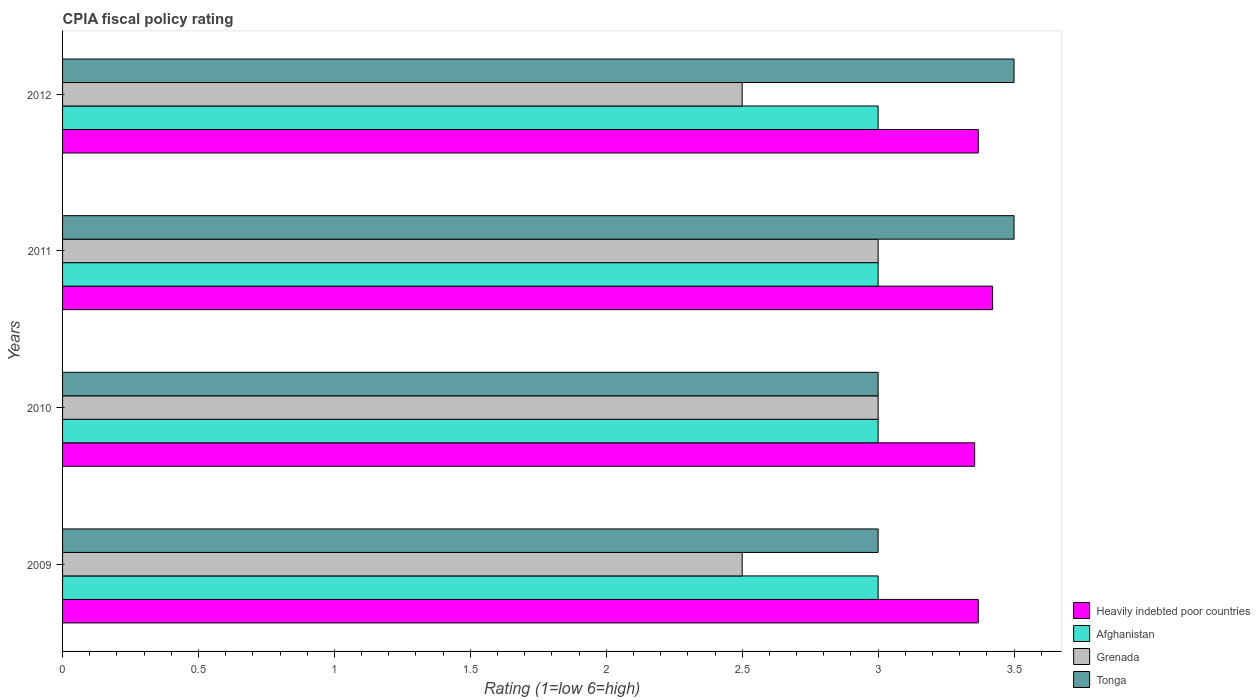How many groups of bars are there?
Offer a very short reply. 4. Are the number of bars per tick equal to the number of legend labels?
Ensure brevity in your answer.  Yes. Are the number of bars on each tick of the Y-axis equal?
Your answer should be very brief. Yes. How many bars are there on the 2nd tick from the top?
Your answer should be compact. 4. Across all years, what is the maximum CPIA rating in Grenada?
Keep it short and to the point. 3. Across all years, what is the minimum CPIA rating in Heavily indebted poor countries?
Keep it short and to the point. 3.36. In which year was the CPIA rating in Tonga maximum?
Your answer should be very brief. 2011. In which year was the CPIA rating in Afghanistan minimum?
Offer a very short reply. 2009. What is the difference between the CPIA rating in Grenada in 2009 and that in 2010?
Offer a terse response. -0.5. What is the difference between the CPIA rating in Grenada in 2009 and the CPIA rating in Tonga in 2011?
Keep it short and to the point. -1. What is the average CPIA rating in Grenada per year?
Your response must be concise. 2.75. In the year 2010, what is the difference between the CPIA rating in Grenada and CPIA rating in Heavily indebted poor countries?
Offer a very short reply. -0.36. In how many years, is the CPIA rating in Tonga greater than 0.7 ?
Make the answer very short. 4. What is the ratio of the CPIA rating in Heavily indebted poor countries in 2009 to that in 2010?
Your answer should be very brief. 1. What is the difference between the highest and the second highest CPIA rating in Heavily indebted poor countries?
Offer a terse response. 0.05. Is it the case that in every year, the sum of the CPIA rating in Heavily indebted poor countries and CPIA rating in Tonga is greater than the sum of CPIA rating in Grenada and CPIA rating in Afghanistan?
Your answer should be compact. No. What does the 2nd bar from the top in 2010 represents?
Your answer should be very brief. Grenada. What does the 3rd bar from the bottom in 2009 represents?
Your response must be concise. Grenada. How many bars are there?
Give a very brief answer. 16. Are the values on the major ticks of X-axis written in scientific E-notation?
Offer a very short reply. No. How are the legend labels stacked?
Provide a short and direct response. Vertical. What is the title of the graph?
Offer a terse response. CPIA fiscal policy rating. What is the Rating (1=low 6=high) of Heavily indebted poor countries in 2009?
Your response must be concise. 3.37. What is the Rating (1=low 6=high) of Afghanistan in 2009?
Give a very brief answer. 3. What is the Rating (1=low 6=high) in Tonga in 2009?
Keep it short and to the point. 3. What is the Rating (1=low 6=high) of Heavily indebted poor countries in 2010?
Ensure brevity in your answer.  3.36. What is the Rating (1=low 6=high) in Grenada in 2010?
Keep it short and to the point. 3. What is the Rating (1=low 6=high) in Tonga in 2010?
Provide a succinct answer. 3. What is the Rating (1=low 6=high) of Heavily indebted poor countries in 2011?
Provide a short and direct response. 3.42. What is the Rating (1=low 6=high) in Afghanistan in 2011?
Ensure brevity in your answer.  3. What is the Rating (1=low 6=high) of Grenada in 2011?
Your answer should be very brief. 3. What is the Rating (1=low 6=high) in Tonga in 2011?
Offer a very short reply. 3.5. What is the Rating (1=low 6=high) of Heavily indebted poor countries in 2012?
Provide a short and direct response. 3.37. What is the Rating (1=low 6=high) in Grenada in 2012?
Your answer should be compact. 2.5. Across all years, what is the maximum Rating (1=low 6=high) in Heavily indebted poor countries?
Give a very brief answer. 3.42. Across all years, what is the minimum Rating (1=low 6=high) of Heavily indebted poor countries?
Offer a terse response. 3.36. Across all years, what is the minimum Rating (1=low 6=high) in Afghanistan?
Your answer should be very brief. 3. Across all years, what is the minimum Rating (1=low 6=high) in Tonga?
Your answer should be very brief. 3. What is the total Rating (1=low 6=high) of Heavily indebted poor countries in the graph?
Your answer should be very brief. 13.51. What is the total Rating (1=low 6=high) in Grenada in the graph?
Make the answer very short. 11. What is the difference between the Rating (1=low 6=high) in Heavily indebted poor countries in 2009 and that in 2010?
Your response must be concise. 0.01. What is the difference between the Rating (1=low 6=high) in Grenada in 2009 and that in 2010?
Keep it short and to the point. -0.5. What is the difference between the Rating (1=low 6=high) of Tonga in 2009 and that in 2010?
Make the answer very short. 0. What is the difference between the Rating (1=low 6=high) in Heavily indebted poor countries in 2009 and that in 2011?
Your answer should be compact. -0.05. What is the difference between the Rating (1=low 6=high) in Heavily indebted poor countries in 2009 and that in 2012?
Make the answer very short. 0. What is the difference between the Rating (1=low 6=high) in Afghanistan in 2009 and that in 2012?
Make the answer very short. 0. What is the difference between the Rating (1=low 6=high) in Tonga in 2009 and that in 2012?
Offer a very short reply. -0.5. What is the difference between the Rating (1=low 6=high) in Heavily indebted poor countries in 2010 and that in 2011?
Ensure brevity in your answer.  -0.07. What is the difference between the Rating (1=low 6=high) of Grenada in 2010 and that in 2011?
Provide a succinct answer. 0. What is the difference between the Rating (1=low 6=high) of Heavily indebted poor countries in 2010 and that in 2012?
Your answer should be very brief. -0.01. What is the difference between the Rating (1=low 6=high) of Afghanistan in 2010 and that in 2012?
Provide a succinct answer. 0. What is the difference between the Rating (1=low 6=high) in Tonga in 2010 and that in 2012?
Make the answer very short. -0.5. What is the difference between the Rating (1=low 6=high) in Heavily indebted poor countries in 2011 and that in 2012?
Offer a very short reply. 0.05. What is the difference between the Rating (1=low 6=high) in Afghanistan in 2011 and that in 2012?
Provide a succinct answer. 0. What is the difference between the Rating (1=low 6=high) in Heavily indebted poor countries in 2009 and the Rating (1=low 6=high) in Afghanistan in 2010?
Your response must be concise. 0.37. What is the difference between the Rating (1=low 6=high) in Heavily indebted poor countries in 2009 and the Rating (1=low 6=high) in Grenada in 2010?
Your response must be concise. 0.37. What is the difference between the Rating (1=low 6=high) in Heavily indebted poor countries in 2009 and the Rating (1=low 6=high) in Tonga in 2010?
Provide a short and direct response. 0.37. What is the difference between the Rating (1=low 6=high) in Afghanistan in 2009 and the Rating (1=low 6=high) in Grenada in 2010?
Your answer should be very brief. 0. What is the difference between the Rating (1=low 6=high) of Grenada in 2009 and the Rating (1=low 6=high) of Tonga in 2010?
Give a very brief answer. -0.5. What is the difference between the Rating (1=low 6=high) of Heavily indebted poor countries in 2009 and the Rating (1=low 6=high) of Afghanistan in 2011?
Make the answer very short. 0.37. What is the difference between the Rating (1=low 6=high) of Heavily indebted poor countries in 2009 and the Rating (1=low 6=high) of Grenada in 2011?
Your response must be concise. 0.37. What is the difference between the Rating (1=low 6=high) in Heavily indebted poor countries in 2009 and the Rating (1=low 6=high) in Tonga in 2011?
Give a very brief answer. -0.13. What is the difference between the Rating (1=low 6=high) of Afghanistan in 2009 and the Rating (1=low 6=high) of Grenada in 2011?
Provide a succinct answer. 0. What is the difference between the Rating (1=low 6=high) of Heavily indebted poor countries in 2009 and the Rating (1=low 6=high) of Afghanistan in 2012?
Provide a succinct answer. 0.37. What is the difference between the Rating (1=low 6=high) in Heavily indebted poor countries in 2009 and the Rating (1=low 6=high) in Grenada in 2012?
Your response must be concise. 0.87. What is the difference between the Rating (1=low 6=high) in Heavily indebted poor countries in 2009 and the Rating (1=low 6=high) in Tonga in 2012?
Your answer should be compact. -0.13. What is the difference between the Rating (1=low 6=high) of Afghanistan in 2009 and the Rating (1=low 6=high) of Grenada in 2012?
Provide a short and direct response. 0.5. What is the difference between the Rating (1=low 6=high) of Grenada in 2009 and the Rating (1=low 6=high) of Tonga in 2012?
Keep it short and to the point. -1. What is the difference between the Rating (1=low 6=high) of Heavily indebted poor countries in 2010 and the Rating (1=low 6=high) of Afghanistan in 2011?
Give a very brief answer. 0.36. What is the difference between the Rating (1=low 6=high) of Heavily indebted poor countries in 2010 and the Rating (1=low 6=high) of Grenada in 2011?
Your response must be concise. 0.36. What is the difference between the Rating (1=low 6=high) of Heavily indebted poor countries in 2010 and the Rating (1=low 6=high) of Tonga in 2011?
Keep it short and to the point. -0.14. What is the difference between the Rating (1=low 6=high) in Afghanistan in 2010 and the Rating (1=low 6=high) in Grenada in 2011?
Your answer should be compact. 0. What is the difference between the Rating (1=low 6=high) of Heavily indebted poor countries in 2010 and the Rating (1=low 6=high) of Afghanistan in 2012?
Your answer should be compact. 0.36. What is the difference between the Rating (1=low 6=high) in Heavily indebted poor countries in 2010 and the Rating (1=low 6=high) in Grenada in 2012?
Offer a very short reply. 0.86. What is the difference between the Rating (1=low 6=high) in Heavily indebted poor countries in 2010 and the Rating (1=low 6=high) in Tonga in 2012?
Keep it short and to the point. -0.14. What is the difference between the Rating (1=low 6=high) in Afghanistan in 2010 and the Rating (1=low 6=high) in Grenada in 2012?
Give a very brief answer. 0.5. What is the difference between the Rating (1=low 6=high) of Afghanistan in 2010 and the Rating (1=low 6=high) of Tonga in 2012?
Offer a terse response. -0.5. What is the difference between the Rating (1=low 6=high) of Grenada in 2010 and the Rating (1=low 6=high) of Tonga in 2012?
Offer a terse response. -0.5. What is the difference between the Rating (1=low 6=high) of Heavily indebted poor countries in 2011 and the Rating (1=low 6=high) of Afghanistan in 2012?
Provide a succinct answer. 0.42. What is the difference between the Rating (1=low 6=high) of Heavily indebted poor countries in 2011 and the Rating (1=low 6=high) of Grenada in 2012?
Provide a short and direct response. 0.92. What is the difference between the Rating (1=low 6=high) of Heavily indebted poor countries in 2011 and the Rating (1=low 6=high) of Tonga in 2012?
Your answer should be compact. -0.08. What is the difference between the Rating (1=low 6=high) in Afghanistan in 2011 and the Rating (1=low 6=high) in Tonga in 2012?
Ensure brevity in your answer.  -0.5. What is the difference between the Rating (1=low 6=high) of Grenada in 2011 and the Rating (1=low 6=high) of Tonga in 2012?
Provide a succinct answer. -0.5. What is the average Rating (1=low 6=high) in Heavily indebted poor countries per year?
Keep it short and to the point. 3.38. What is the average Rating (1=low 6=high) of Afghanistan per year?
Offer a terse response. 3. What is the average Rating (1=low 6=high) of Grenada per year?
Offer a very short reply. 2.75. What is the average Rating (1=low 6=high) of Tonga per year?
Provide a short and direct response. 3.25. In the year 2009, what is the difference between the Rating (1=low 6=high) of Heavily indebted poor countries and Rating (1=low 6=high) of Afghanistan?
Give a very brief answer. 0.37. In the year 2009, what is the difference between the Rating (1=low 6=high) in Heavily indebted poor countries and Rating (1=low 6=high) in Grenada?
Your response must be concise. 0.87. In the year 2009, what is the difference between the Rating (1=low 6=high) of Heavily indebted poor countries and Rating (1=low 6=high) of Tonga?
Offer a very short reply. 0.37. In the year 2009, what is the difference between the Rating (1=low 6=high) in Afghanistan and Rating (1=low 6=high) in Tonga?
Your answer should be very brief. 0. In the year 2009, what is the difference between the Rating (1=low 6=high) in Grenada and Rating (1=low 6=high) in Tonga?
Provide a succinct answer. -0.5. In the year 2010, what is the difference between the Rating (1=low 6=high) in Heavily indebted poor countries and Rating (1=low 6=high) in Afghanistan?
Give a very brief answer. 0.36. In the year 2010, what is the difference between the Rating (1=low 6=high) of Heavily indebted poor countries and Rating (1=low 6=high) of Grenada?
Offer a very short reply. 0.36. In the year 2010, what is the difference between the Rating (1=low 6=high) of Heavily indebted poor countries and Rating (1=low 6=high) of Tonga?
Provide a succinct answer. 0.36. In the year 2010, what is the difference between the Rating (1=low 6=high) in Afghanistan and Rating (1=low 6=high) in Grenada?
Make the answer very short. 0. In the year 2011, what is the difference between the Rating (1=low 6=high) of Heavily indebted poor countries and Rating (1=low 6=high) of Afghanistan?
Provide a succinct answer. 0.42. In the year 2011, what is the difference between the Rating (1=low 6=high) in Heavily indebted poor countries and Rating (1=low 6=high) in Grenada?
Ensure brevity in your answer.  0.42. In the year 2011, what is the difference between the Rating (1=low 6=high) in Heavily indebted poor countries and Rating (1=low 6=high) in Tonga?
Offer a very short reply. -0.08. In the year 2011, what is the difference between the Rating (1=low 6=high) in Afghanistan and Rating (1=low 6=high) in Grenada?
Offer a very short reply. 0. In the year 2012, what is the difference between the Rating (1=low 6=high) in Heavily indebted poor countries and Rating (1=low 6=high) in Afghanistan?
Make the answer very short. 0.37. In the year 2012, what is the difference between the Rating (1=low 6=high) in Heavily indebted poor countries and Rating (1=low 6=high) in Grenada?
Your answer should be compact. 0.87. In the year 2012, what is the difference between the Rating (1=low 6=high) of Heavily indebted poor countries and Rating (1=low 6=high) of Tonga?
Make the answer very short. -0.13. In the year 2012, what is the difference between the Rating (1=low 6=high) in Afghanistan and Rating (1=low 6=high) in Grenada?
Offer a very short reply. 0.5. In the year 2012, what is the difference between the Rating (1=low 6=high) of Afghanistan and Rating (1=low 6=high) of Tonga?
Keep it short and to the point. -0.5. In the year 2012, what is the difference between the Rating (1=low 6=high) in Grenada and Rating (1=low 6=high) in Tonga?
Offer a very short reply. -1. What is the ratio of the Rating (1=low 6=high) of Tonga in 2009 to that in 2010?
Make the answer very short. 1. What is the ratio of the Rating (1=low 6=high) of Heavily indebted poor countries in 2009 to that in 2011?
Offer a terse response. 0.98. What is the ratio of the Rating (1=low 6=high) of Afghanistan in 2009 to that in 2011?
Offer a terse response. 1. What is the ratio of the Rating (1=low 6=high) of Grenada in 2009 to that in 2011?
Give a very brief answer. 0.83. What is the ratio of the Rating (1=low 6=high) of Tonga in 2009 to that in 2012?
Give a very brief answer. 0.86. What is the ratio of the Rating (1=low 6=high) of Heavily indebted poor countries in 2010 to that in 2011?
Your answer should be compact. 0.98. What is the ratio of the Rating (1=low 6=high) of Afghanistan in 2010 to that in 2011?
Provide a succinct answer. 1. What is the ratio of the Rating (1=low 6=high) of Afghanistan in 2010 to that in 2012?
Provide a succinct answer. 1. What is the ratio of the Rating (1=low 6=high) in Heavily indebted poor countries in 2011 to that in 2012?
Make the answer very short. 1.02. What is the ratio of the Rating (1=low 6=high) in Grenada in 2011 to that in 2012?
Provide a succinct answer. 1.2. What is the ratio of the Rating (1=low 6=high) in Tonga in 2011 to that in 2012?
Your answer should be very brief. 1. What is the difference between the highest and the second highest Rating (1=low 6=high) in Heavily indebted poor countries?
Offer a very short reply. 0.05. What is the difference between the highest and the second highest Rating (1=low 6=high) in Tonga?
Provide a short and direct response. 0. What is the difference between the highest and the lowest Rating (1=low 6=high) in Heavily indebted poor countries?
Provide a short and direct response. 0.07. What is the difference between the highest and the lowest Rating (1=low 6=high) of Grenada?
Your answer should be compact. 0.5. What is the difference between the highest and the lowest Rating (1=low 6=high) of Tonga?
Keep it short and to the point. 0.5. 